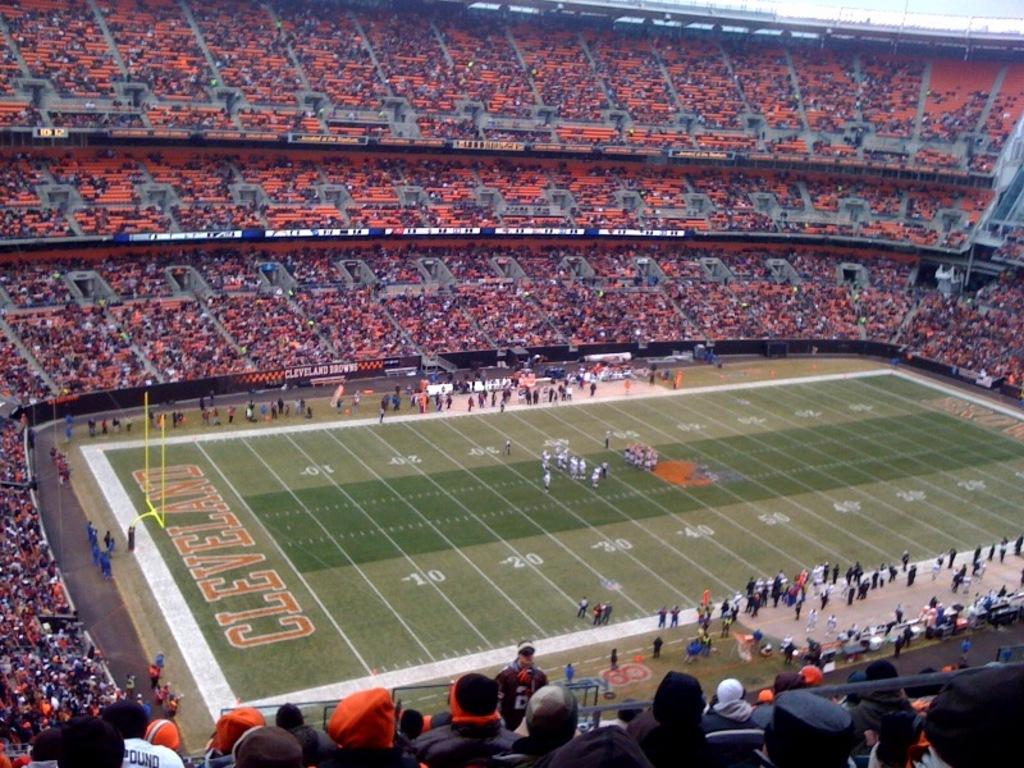Provide a one-sentence caption for the provided image. the football feild is getting ready for the Cleveland game. 